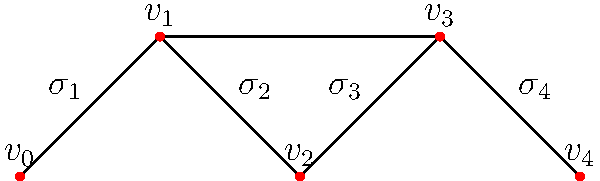Consider the simplicial complex representing a hierarchical social structure from a historical era. The vertices represent individuals, and the simplices represent social groups. Calculate the Euler characteristic of this structure and interpret its significance in terms of social cohesion. To solve this problem, we'll follow these steps:

1. Identify the components of the simplicial complex:
   - 0-simplices (vertices): $v_0$, $v_1$, $v_2$, $v_3$, $v_4$
   - 1-simplices (edges): $(v_0,v_1)$, $(v_1,v_2)$, $(v_2,v_3)$, $(v_3,v_4)$, $(v_1,v_3)$
   - 2-simplices (triangles): none

2. Count the number of simplices:
   - $f_0 = 5$ (0-simplices)
   - $f_1 = 5$ (1-simplices)
   - $f_2 = 0$ (2-simplices)

3. Calculate the Euler characteristic using the formula:
   $\chi = f_0 - f_1 + f_2$
   $\chi = 5 - 5 + 0 = 0$

4. Interpret the result:
   The Euler characteristic of 0 suggests a balance between the number of individuals and social connections. In sociological terms, this can be interpreted as:
   
   a) The structure has a cyclic nature, indicating a closed social system.
   b) There's a balance between social fragmentation (represented by vertices) and cohesion (represented by edges).
   c) The society represented by this structure may be stable but not highly integrated, as there are no higher-order simplices (triangles) representing more complex group interactions.

This analysis provides insights into the social dynamics of the historical era represented by the simplicial complex, highlighting a structure that maintains equilibrium between individual autonomy and social connections.
Answer: Euler characteristic: 0; Indicates balanced, cyclic social structure with moderate cohesion. 